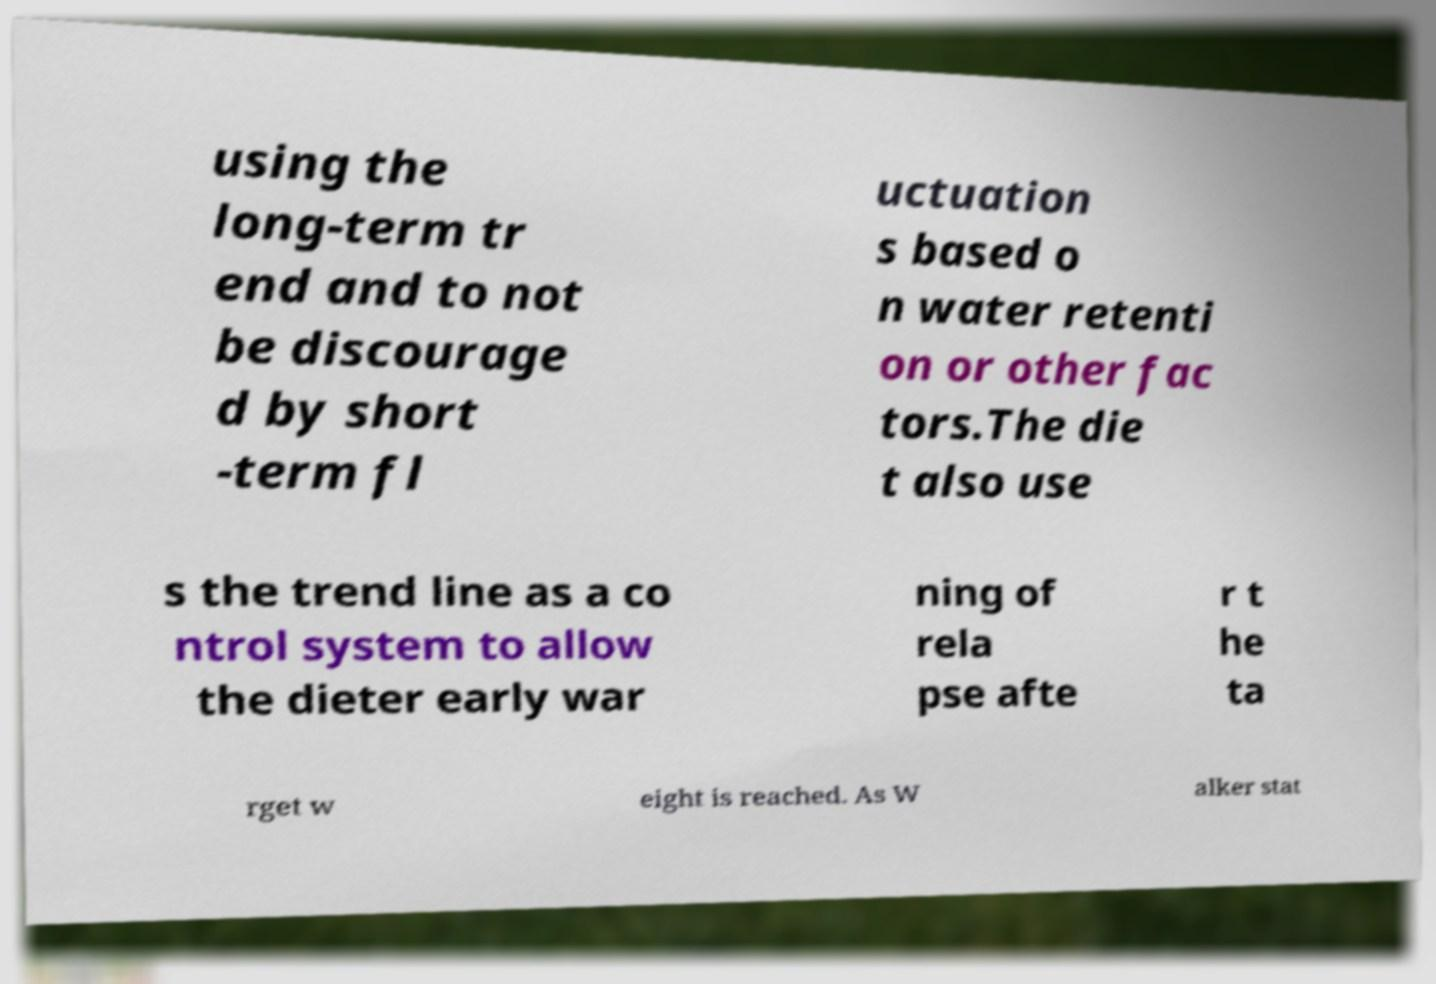Can you read and provide the text displayed in the image?This photo seems to have some interesting text. Can you extract and type it out for me? using the long-term tr end and to not be discourage d by short -term fl uctuation s based o n water retenti on or other fac tors.The die t also use s the trend line as a co ntrol system to allow the dieter early war ning of rela pse afte r t he ta rget w eight is reached. As W alker stat 